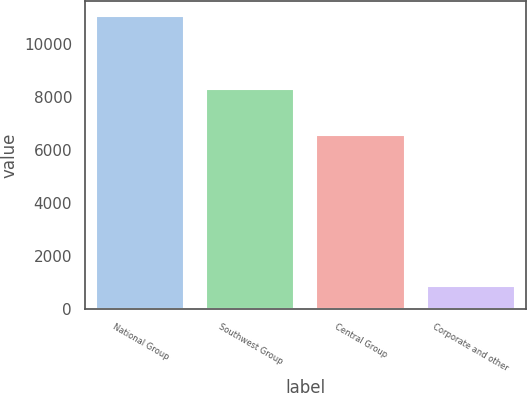<chart> <loc_0><loc_0><loc_500><loc_500><bar_chart><fcel>National Group<fcel>Southwest Group<fcel>Central Group<fcel>Corporate and other<nl><fcel>11047<fcel>8282<fcel>6570<fcel>877<nl></chart> 